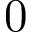<formula> <loc_0><loc_0><loc_500><loc_500>0</formula> 